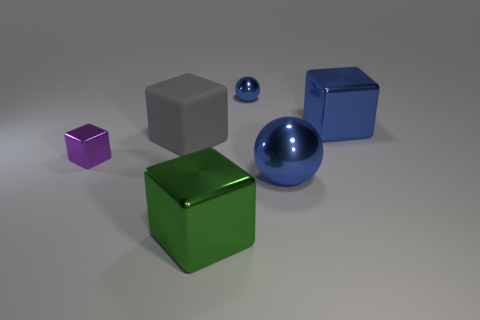Is there a large object that has the same material as the tiny purple block?
Provide a succinct answer. Yes. What is the shape of the big matte thing?
Make the answer very short. Cube. The other small object that is made of the same material as the small blue object is what color?
Provide a short and direct response. Purple. How many gray objects are either big metal cubes or large spheres?
Your answer should be very brief. 0. Is the number of small green shiny spheres greater than the number of green objects?
Your response must be concise. No. How many objects are either metallic cubes that are to the right of the small shiny cube or big metal cubes that are on the left side of the large blue ball?
Ensure brevity in your answer.  2. There is a ball that is the same size as the gray matte object; what is its color?
Give a very brief answer. Blue. Does the large green object have the same material as the tiny block?
Offer a very short reply. Yes. There is a large cube on the right side of the blue ball behind the big shiny sphere; what is its material?
Keep it short and to the point. Metal. Are there more tiny purple objects that are on the left side of the tiny blue metal sphere than small gray metal spheres?
Your response must be concise. Yes. 